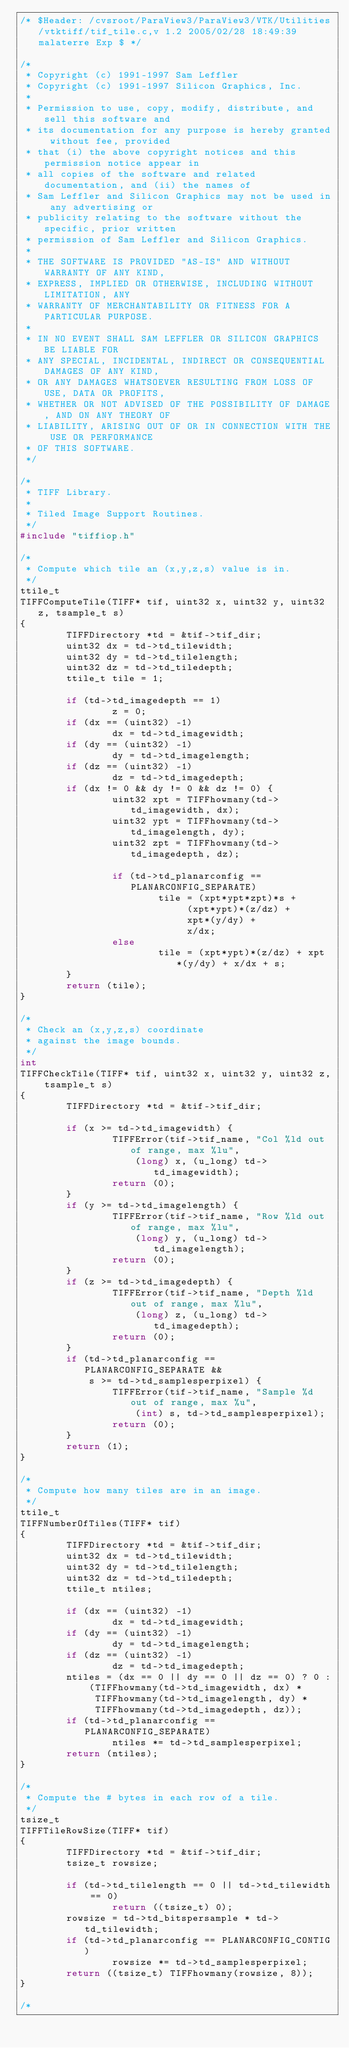<code> <loc_0><loc_0><loc_500><loc_500><_C_>/* $Header: /cvsroot/ParaView3/ParaView3/VTK/Utilities/vtktiff/tif_tile.c,v 1.2 2005/02/28 18:49:39 malaterre Exp $ */

/*
 * Copyright (c) 1991-1997 Sam Leffler
 * Copyright (c) 1991-1997 Silicon Graphics, Inc.
 *
 * Permission to use, copy, modify, distribute, and sell this software and 
 * its documentation for any purpose is hereby granted without fee, provided
 * that (i) the above copyright notices and this permission notice appear in
 * all copies of the software and related documentation, and (ii) the names of
 * Sam Leffler and Silicon Graphics may not be used in any advertising or
 * publicity relating to the software without the specific, prior written
 * permission of Sam Leffler and Silicon Graphics.
 * 
 * THE SOFTWARE IS PROVIDED "AS-IS" AND WITHOUT WARRANTY OF ANY KIND, 
 * EXPRESS, IMPLIED OR OTHERWISE, INCLUDING WITHOUT LIMITATION, ANY 
 * WARRANTY OF MERCHANTABILITY OR FITNESS FOR A PARTICULAR PURPOSE.  
 * 
 * IN NO EVENT SHALL SAM LEFFLER OR SILICON GRAPHICS BE LIABLE FOR
 * ANY SPECIAL, INCIDENTAL, INDIRECT OR CONSEQUENTIAL DAMAGES OF ANY KIND,
 * OR ANY DAMAGES WHATSOEVER RESULTING FROM LOSS OF USE, DATA OR PROFITS,
 * WHETHER OR NOT ADVISED OF THE POSSIBILITY OF DAMAGE, AND ON ANY THEORY OF 
 * LIABILITY, ARISING OUT OF OR IN CONNECTION WITH THE USE OR PERFORMANCE 
 * OF THIS SOFTWARE.
 */

/*
 * TIFF Library.
 *
 * Tiled Image Support Routines.
 */
#include "tiffiop.h"

/*
 * Compute which tile an (x,y,z,s) value is in.
 */
ttile_t
TIFFComputeTile(TIFF* tif, uint32 x, uint32 y, uint32 z, tsample_t s)
{
        TIFFDirectory *td = &tif->tif_dir;
        uint32 dx = td->td_tilewidth;
        uint32 dy = td->td_tilelength;
        uint32 dz = td->td_tiledepth;
        ttile_t tile = 1;

        if (td->td_imagedepth == 1)
                z = 0;
        if (dx == (uint32) -1)
                dx = td->td_imagewidth;
        if (dy == (uint32) -1)
                dy = td->td_imagelength;
        if (dz == (uint32) -1)
                dz = td->td_imagedepth;
        if (dx != 0 && dy != 0 && dz != 0) {
                uint32 xpt = TIFFhowmany(td->td_imagewidth, dx); 
                uint32 ypt = TIFFhowmany(td->td_imagelength, dy); 
                uint32 zpt = TIFFhowmany(td->td_imagedepth, dz); 

                if (td->td_planarconfig == PLANARCONFIG_SEPARATE) 
                        tile = (xpt*ypt*zpt)*s +
                             (xpt*ypt)*(z/dz) +
                             xpt*(y/dy) +
                             x/dx;
                else
                        tile = (xpt*ypt)*(z/dz) + xpt*(y/dy) + x/dx + s;
        }
        return (tile);
}

/*
 * Check an (x,y,z,s) coordinate
 * against the image bounds.
 */
int
TIFFCheckTile(TIFF* tif, uint32 x, uint32 y, uint32 z, tsample_t s)
{
        TIFFDirectory *td = &tif->tif_dir;

        if (x >= td->td_imagewidth) {
                TIFFError(tif->tif_name, "Col %ld out of range, max %lu",
                    (long) x, (u_long) td->td_imagewidth);
                return (0);
        }
        if (y >= td->td_imagelength) {
                TIFFError(tif->tif_name, "Row %ld out of range, max %lu",
                    (long) y, (u_long) td->td_imagelength);
                return (0);
        }
        if (z >= td->td_imagedepth) {
                TIFFError(tif->tif_name, "Depth %ld out of range, max %lu",
                    (long) z, (u_long) td->td_imagedepth);
                return (0);
        }
        if (td->td_planarconfig == PLANARCONFIG_SEPARATE &&
            s >= td->td_samplesperpixel) {
                TIFFError(tif->tif_name, "Sample %d out of range, max %u",
                    (int) s, td->td_samplesperpixel);
                return (0);
        }
        return (1);
}

/*
 * Compute how many tiles are in an image.
 */
ttile_t
TIFFNumberOfTiles(TIFF* tif)
{
        TIFFDirectory *td = &tif->tif_dir;
        uint32 dx = td->td_tilewidth;
        uint32 dy = td->td_tilelength;
        uint32 dz = td->td_tiledepth;
        ttile_t ntiles;

        if (dx == (uint32) -1)
                dx = td->td_imagewidth;
        if (dy == (uint32) -1)
                dy = td->td_imagelength;
        if (dz == (uint32) -1)
                dz = td->td_imagedepth;
        ntiles = (dx == 0 || dy == 0 || dz == 0) ? 0 :
            (TIFFhowmany(td->td_imagewidth, dx) *
             TIFFhowmany(td->td_imagelength, dy) *
             TIFFhowmany(td->td_imagedepth, dz));
        if (td->td_planarconfig == PLANARCONFIG_SEPARATE)
                ntiles *= td->td_samplesperpixel;
        return (ntiles);
}

/*
 * Compute the # bytes in each row of a tile.
 */
tsize_t
TIFFTileRowSize(TIFF* tif)
{
        TIFFDirectory *td = &tif->tif_dir;
        tsize_t rowsize;
        
        if (td->td_tilelength == 0 || td->td_tilewidth == 0)
                return ((tsize_t) 0);
        rowsize = td->td_bitspersample * td->td_tilewidth;
        if (td->td_planarconfig == PLANARCONFIG_CONTIG)
                rowsize *= td->td_samplesperpixel;
        return ((tsize_t) TIFFhowmany(rowsize, 8));
}

/*</code> 